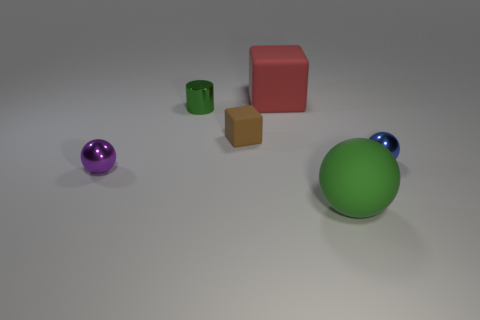How many other things are there of the same size as the green metal cylinder?
Ensure brevity in your answer.  3. There is a large thing that is behind the tiny metal ball that is to the right of the green ball; are there any matte objects to the right of it?
Offer a very short reply. Yes. Are the small ball on the right side of the large green sphere and the big ball made of the same material?
Offer a terse response. No. There is another tiny metal thing that is the same shape as the purple metallic object; what is its color?
Offer a very short reply. Blue. Is there any other thing that has the same shape as the tiny green metal object?
Offer a terse response. No. Are there the same number of matte blocks that are to the left of the purple metallic object and large red objects?
Keep it short and to the point. No. There is a small green thing; are there any large rubber blocks on the right side of it?
Give a very brief answer. Yes. What size is the green shiny thing behind the small shiny ball that is on the right side of the cube that is behind the tiny brown cube?
Give a very brief answer. Small. Does the small object on the right side of the brown matte cube have the same shape as the matte thing in front of the purple metallic object?
Offer a terse response. Yes. There is a green rubber thing that is the same shape as the purple metal thing; what size is it?
Keep it short and to the point. Large. 